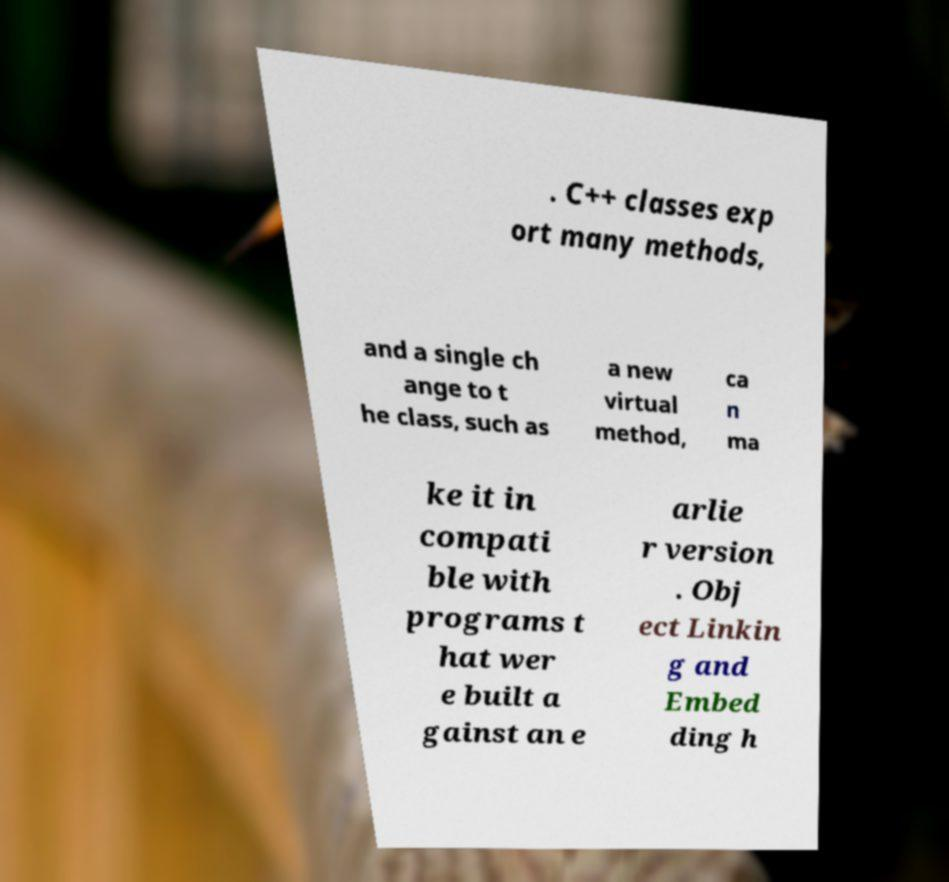There's text embedded in this image that I need extracted. Can you transcribe it verbatim? . C++ classes exp ort many methods, and a single ch ange to t he class, such as a new virtual method, ca n ma ke it in compati ble with programs t hat wer e built a gainst an e arlie r version . Obj ect Linkin g and Embed ding h 